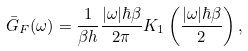<formula> <loc_0><loc_0><loc_500><loc_500>\bar { G } _ { F } ( \omega ) = \frac { 1 } { \beta h } \frac { | \omega | \hbar { \beta } } { 2 \pi } K _ { 1 } \left ( \frac { | \omega | \hbar { \beta } } { 2 } \right ) ,</formula> 